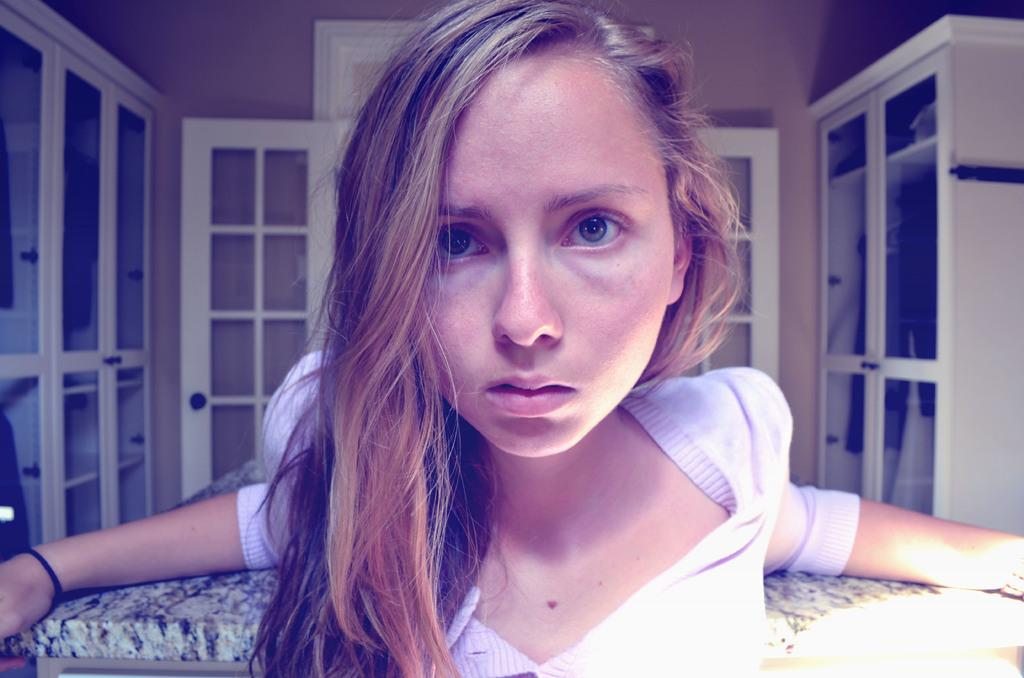What type of location is depicted in the image? The image is an inside view of a room. Who is present in the room? There is a woman in the room. What is the woman doing in the image? The woman is looking at a picture. What furniture can be seen in the room? There is a table in the room. What architectural features are visible in the background of the room? There are cupboards and a wall visible in the background of the room. What type of peace symbol can be seen on the wall in the image? There is no peace symbol visible on the wall in the image. How many potatoes are present on the table in the image? There are no potatoes present on the table in the image. 